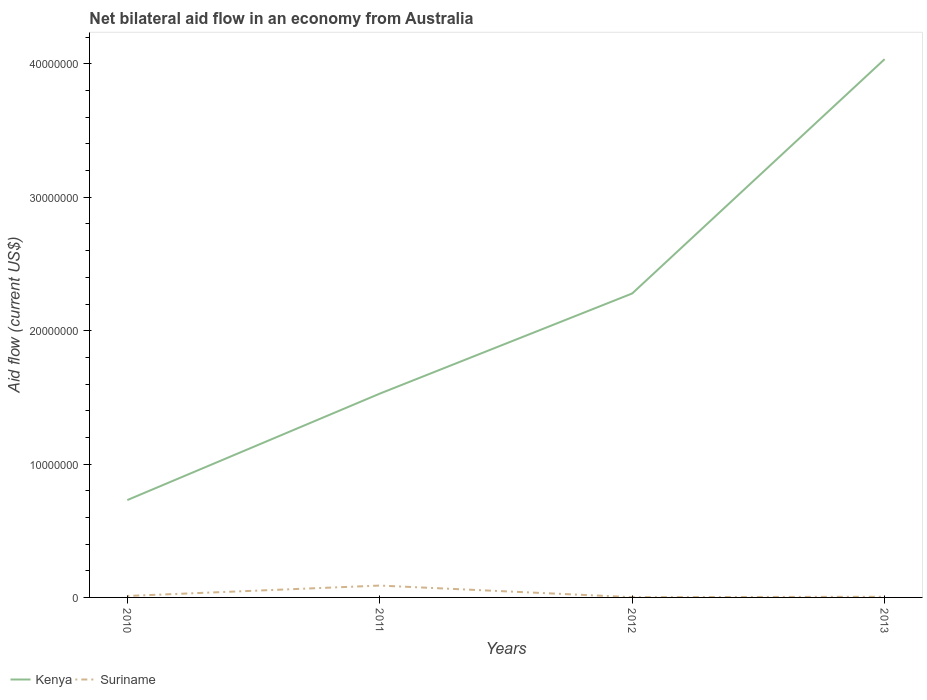Is the number of lines equal to the number of legend labels?
Keep it short and to the point. Yes. What is the total net bilateral aid flow in Suriname in the graph?
Offer a very short reply. 6.00e+04. What is the difference between the highest and the second highest net bilateral aid flow in Suriname?
Ensure brevity in your answer.  8.70e+05. What is the difference between the highest and the lowest net bilateral aid flow in Kenya?
Your response must be concise. 2. Is the net bilateral aid flow in Suriname strictly greater than the net bilateral aid flow in Kenya over the years?
Offer a very short reply. Yes. Are the values on the major ticks of Y-axis written in scientific E-notation?
Keep it short and to the point. No. Does the graph contain grids?
Provide a succinct answer. No. How are the legend labels stacked?
Your answer should be compact. Horizontal. What is the title of the graph?
Ensure brevity in your answer.  Net bilateral aid flow in an economy from Australia. What is the label or title of the Y-axis?
Make the answer very short. Aid flow (current US$). What is the Aid flow (current US$) in Kenya in 2010?
Provide a succinct answer. 7.30e+06. What is the Aid flow (current US$) in Suriname in 2010?
Offer a terse response. 1.10e+05. What is the Aid flow (current US$) of Kenya in 2011?
Offer a very short reply. 1.53e+07. What is the Aid flow (current US$) of Suriname in 2011?
Your response must be concise. 8.90e+05. What is the Aid flow (current US$) of Kenya in 2012?
Your answer should be very brief. 2.28e+07. What is the Aid flow (current US$) in Kenya in 2013?
Offer a terse response. 4.04e+07. What is the Aid flow (current US$) in Suriname in 2013?
Provide a succinct answer. 5.00e+04. Across all years, what is the maximum Aid flow (current US$) in Kenya?
Ensure brevity in your answer.  4.04e+07. Across all years, what is the maximum Aid flow (current US$) in Suriname?
Keep it short and to the point. 8.90e+05. Across all years, what is the minimum Aid flow (current US$) in Kenya?
Your answer should be very brief. 7.30e+06. What is the total Aid flow (current US$) of Kenya in the graph?
Your response must be concise. 8.57e+07. What is the total Aid flow (current US$) of Suriname in the graph?
Make the answer very short. 1.07e+06. What is the difference between the Aid flow (current US$) of Kenya in 2010 and that in 2011?
Your answer should be very brief. -7.98e+06. What is the difference between the Aid flow (current US$) of Suriname in 2010 and that in 2011?
Your response must be concise. -7.80e+05. What is the difference between the Aid flow (current US$) of Kenya in 2010 and that in 2012?
Your answer should be very brief. -1.55e+07. What is the difference between the Aid flow (current US$) in Suriname in 2010 and that in 2012?
Keep it short and to the point. 9.00e+04. What is the difference between the Aid flow (current US$) of Kenya in 2010 and that in 2013?
Keep it short and to the point. -3.31e+07. What is the difference between the Aid flow (current US$) in Kenya in 2011 and that in 2012?
Your response must be concise. -7.51e+06. What is the difference between the Aid flow (current US$) in Suriname in 2011 and that in 2012?
Your answer should be very brief. 8.70e+05. What is the difference between the Aid flow (current US$) in Kenya in 2011 and that in 2013?
Keep it short and to the point. -2.51e+07. What is the difference between the Aid flow (current US$) in Suriname in 2011 and that in 2013?
Ensure brevity in your answer.  8.40e+05. What is the difference between the Aid flow (current US$) in Kenya in 2012 and that in 2013?
Offer a very short reply. -1.76e+07. What is the difference between the Aid flow (current US$) of Suriname in 2012 and that in 2013?
Keep it short and to the point. -3.00e+04. What is the difference between the Aid flow (current US$) of Kenya in 2010 and the Aid flow (current US$) of Suriname in 2011?
Ensure brevity in your answer.  6.41e+06. What is the difference between the Aid flow (current US$) of Kenya in 2010 and the Aid flow (current US$) of Suriname in 2012?
Your response must be concise. 7.28e+06. What is the difference between the Aid flow (current US$) of Kenya in 2010 and the Aid flow (current US$) of Suriname in 2013?
Keep it short and to the point. 7.25e+06. What is the difference between the Aid flow (current US$) of Kenya in 2011 and the Aid flow (current US$) of Suriname in 2012?
Give a very brief answer. 1.53e+07. What is the difference between the Aid flow (current US$) in Kenya in 2011 and the Aid flow (current US$) in Suriname in 2013?
Ensure brevity in your answer.  1.52e+07. What is the difference between the Aid flow (current US$) of Kenya in 2012 and the Aid flow (current US$) of Suriname in 2013?
Give a very brief answer. 2.27e+07. What is the average Aid flow (current US$) of Kenya per year?
Make the answer very short. 2.14e+07. What is the average Aid flow (current US$) of Suriname per year?
Provide a short and direct response. 2.68e+05. In the year 2010, what is the difference between the Aid flow (current US$) of Kenya and Aid flow (current US$) of Suriname?
Make the answer very short. 7.19e+06. In the year 2011, what is the difference between the Aid flow (current US$) of Kenya and Aid flow (current US$) of Suriname?
Ensure brevity in your answer.  1.44e+07. In the year 2012, what is the difference between the Aid flow (current US$) in Kenya and Aid flow (current US$) in Suriname?
Your answer should be compact. 2.28e+07. In the year 2013, what is the difference between the Aid flow (current US$) in Kenya and Aid flow (current US$) in Suriname?
Provide a short and direct response. 4.03e+07. What is the ratio of the Aid flow (current US$) in Kenya in 2010 to that in 2011?
Provide a succinct answer. 0.48. What is the ratio of the Aid flow (current US$) of Suriname in 2010 to that in 2011?
Make the answer very short. 0.12. What is the ratio of the Aid flow (current US$) in Kenya in 2010 to that in 2012?
Make the answer very short. 0.32. What is the ratio of the Aid flow (current US$) of Suriname in 2010 to that in 2012?
Provide a succinct answer. 5.5. What is the ratio of the Aid flow (current US$) in Kenya in 2010 to that in 2013?
Your answer should be very brief. 0.18. What is the ratio of the Aid flow (current US$) of Kenya in 2011 to that in 2012?
Ensure brevity in your answer.  0.67. What is the ratio of the Aid flow (current US$) of Suriname in 2011 to that in 2012?
Provide a short and direct response. 44.5. What is the ratio of the Aid flow (current US$) in Kenya in 2011 to that in 2013?
Your answer should be compact. 0.38. What is the ratio of the Aid flow (current US$) in Kenya in 2012 to that in 2013?
Ensure brevity in your answer.  0.56. What is the difference between the highest and the second highest Aid flow (current US$) of Kenya?
Give a very brief answer. 1.76e+07. What is the difference between the highest and the second highest Aid flow (current US$) in Suriname?
Offer a terse response. 7.80e+05. What is the difference between the highest and the lowest Aid flow (current US$) of Kenya?
Your answer should be compact. 3.31e+07. What is the difference between the highest and the lowest Aid flow (current US$) of Suriname?
Make the answer very short. 8.70e+05. 